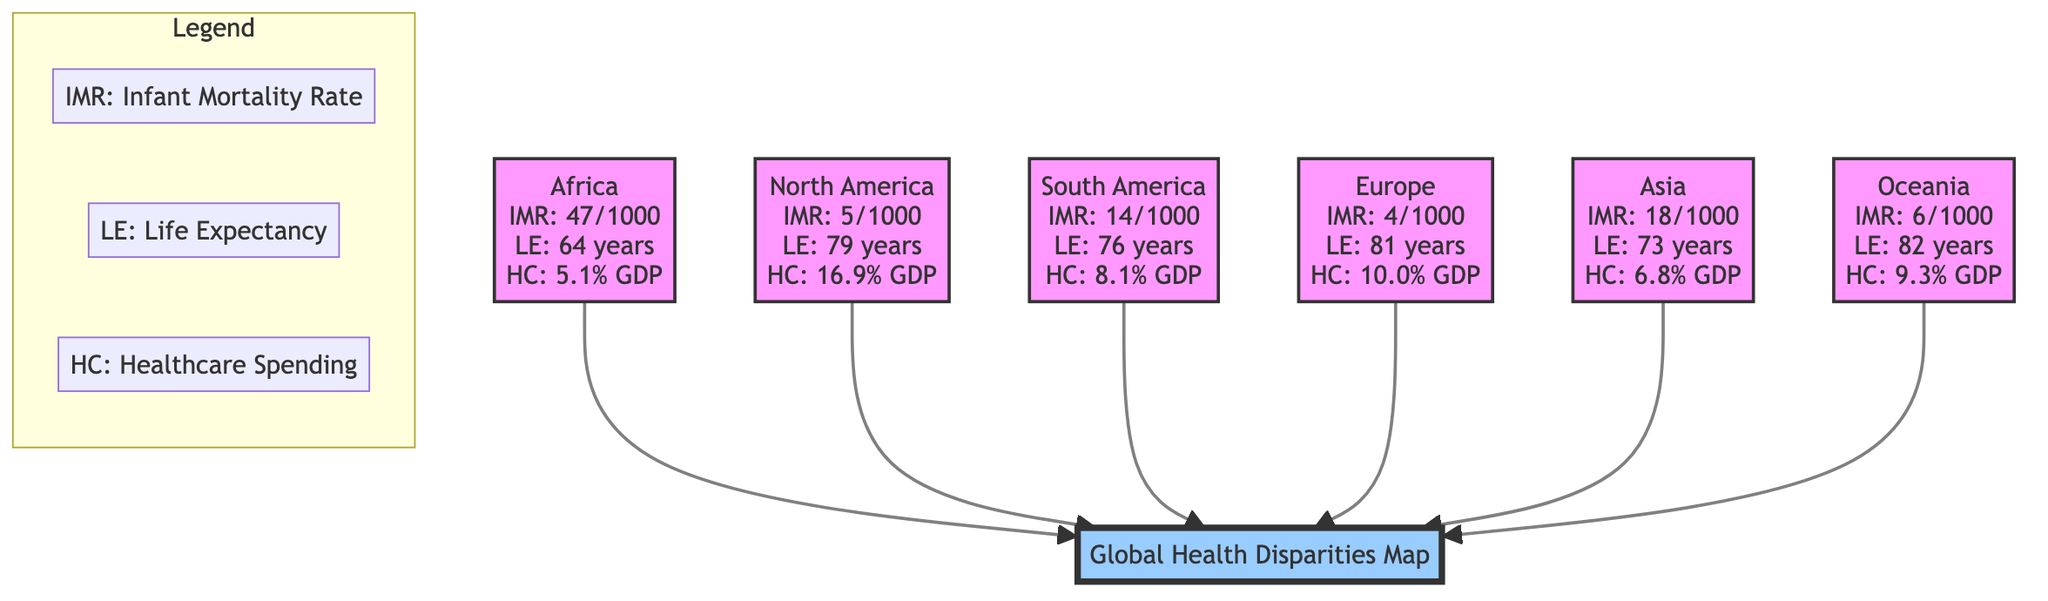What is the infant mortality rate in Africa? The diagram states that the infant mortality rate (IMR) in Africa is represented as "IMR: 47/1000". Hence, by directly referring to the data listed under the Africa node, we find the value.
Answer: 47/1000 What is the life expectancy in Europe? The diagram shows that the life expectancy (LE) in Europe is listed under the Europe node as "LE: 81 years". This information is directly extracted from the specific node, leading us to the answer.
Answer: 81 years Which region has the highest healthcare spending as a percentage of GDP? By comparing the healthcare spending (HC) percentages listed in each region, we observe that North America has "HC: 16.9% GDP", while all other regions have lower values. Therefore, we conclude that North America has the highest healthcare spending.
Answer: North America What is the relationship between infant mortality rate and life expectancy in Asia? In Asia, the diagram specifies "IMR: 18/1000" and "LE: 73 years". Generally, higher infant mortality rates correspond to lower life expectancy, indicating a negative correlation between these two metrics in this context.
Answer: Negative correlation How many regions have an infant mortality rate lower than 10 per 1000? The diagram lists the infant mortality rates: Africa (47), North America (5), South America (14), Europe (4), Asia (18), and Oceania (6). Only North America (5) and Europe (4) have rates lower than 10, resulting in a count of 2.
Answer: 2 Which region has the lowest infant mortality rate? By analyzing the IMR values of each region, we find that the lowest IMR is "4/1000" found in Europe. Thus, Europe has the least infant mortality rate among the regions displayed.
Answer: Europe What is the healthcare spending in South America? The diagram indicates that in South America, healthcare spending (HC) is "HC: 8.1% GDP". This information is directly taken from the South America node in the diagram.
Answer: 8.1% GDP In which region is life expectancy closest to 75 years? Looking at the life expectancy (LE) values, North America (79 years), South America (76 years), Asia (73 years), and Africa (64 years) are evaluated. South America, with 76 years, is the closest to 75 years among the options.
Answer: South America 